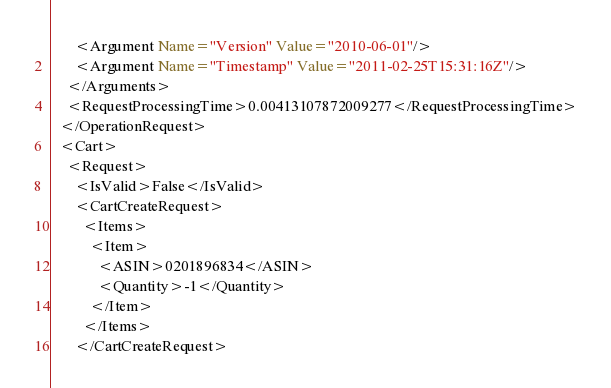Convert code to text. <code><loc_0><loc_0><loc_500><loc_500><_XML_>      <Argument Name="Version" Value="2010-06-01"/>
      <Argument Name="Timestamp" Value="2011-02-25T15:31:16Z"/>
    </Arguments>
    <RequestProcessingTime>0.00413107872009277</RequestProcessingTime>
  </OperationRequest>
  <Cart>
    <Request>
      <IsValid>False</IsValid>
      <CartCreateRequest>
        <Items>
          <Item>
            <ASIN>0201896834</ASIN>
            <Quantity>-1</Quantity>
          </Item>
        </Items>
      </CartCreateRequest></code> 